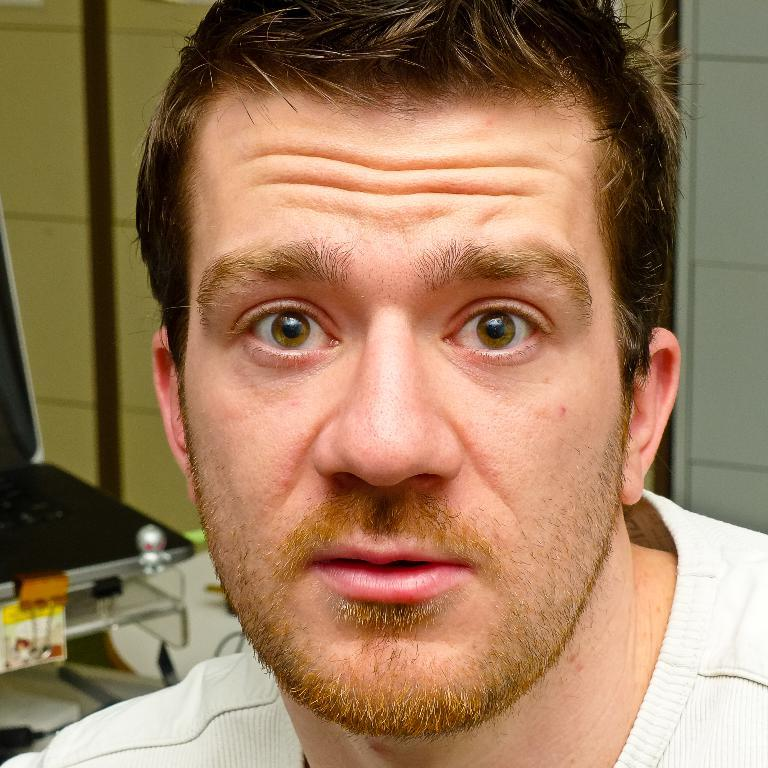Who or what is present in the image? There is a person in the image. What is the person wearing? The person is wearing a white t-shirt. Can you describe any objects or furniture in the image? There is a chair on the left side of the image. How many cushions are on the chair in the image? There is no mention of cushions on the chair in the image; only the chair itself is described. 